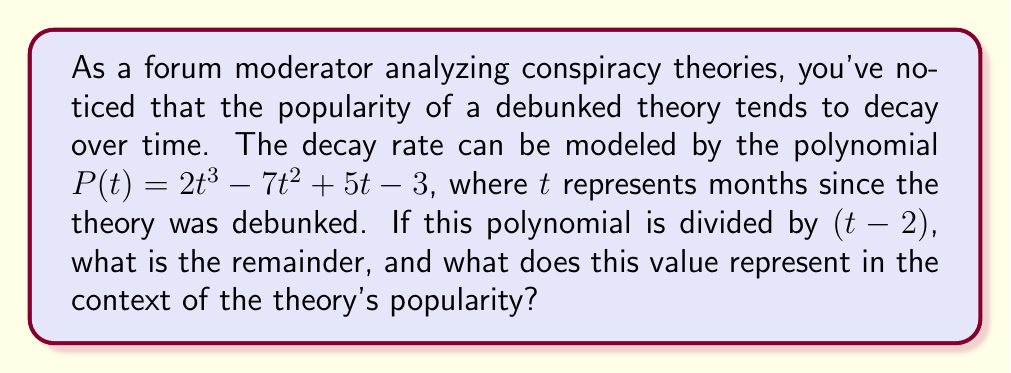Provide a solution to this math problem. To solve this problem, we need to perform polynomial long division of $P(t)$ by $(t-2)$. Let's go through the steps:

1) Set up the polynomial long division:

$$\frac{2t^3 - 7t^2 + 5t - 3}{t - 2}$$

2) Divide $2t^3$ by $t$, getting $2t^2$. Multiply $(t-2)$ by $2t^2$:

   $2t^3 - 4t^2$

3) Subtract this from the numerator:

   $2t^3 - 7t^2 + 5t - 3$
   $-(2t^3 - 4t^2)$
   $= -3t^2 + 5t - 3$

4) Bring down the rest of the numerator. Now divide $-3t^2$ by $t$, getting $-3t$. Multiply $(t-2)$ by $-3t$:

   $-3t^2 + 6t$

5) Subtract:

   $-3t^2 + 5t - 3$
   $-(-3t^2 + 6t)$
   $= -t - 3$

6) Divide $-t$ by $t$, getting $-1$. Multiply $(t-2)$ by $-1$:

   $-t + 2$

7) Subtract:

   $-t - 3$
   $-(-t + 2)$
   $= -5$

The division is complete. The quotient is $2t^2 - 3t - 1$ and the remainder is $-5$.

In the context of the theory's popularity, the remainder of $-5$ represents the residual popularity of the theory after a long time. It suggests that even after many months, there might still be a small, persistent group of believers (represented by the absolute value 5), but the negative sign indicates that this group is in opposition to the general trend or mainstream belief.
Answer: The remainder is $-5$, representing a small, persistent level of belief in the debunked theory, contrary to the general trend of decay. 